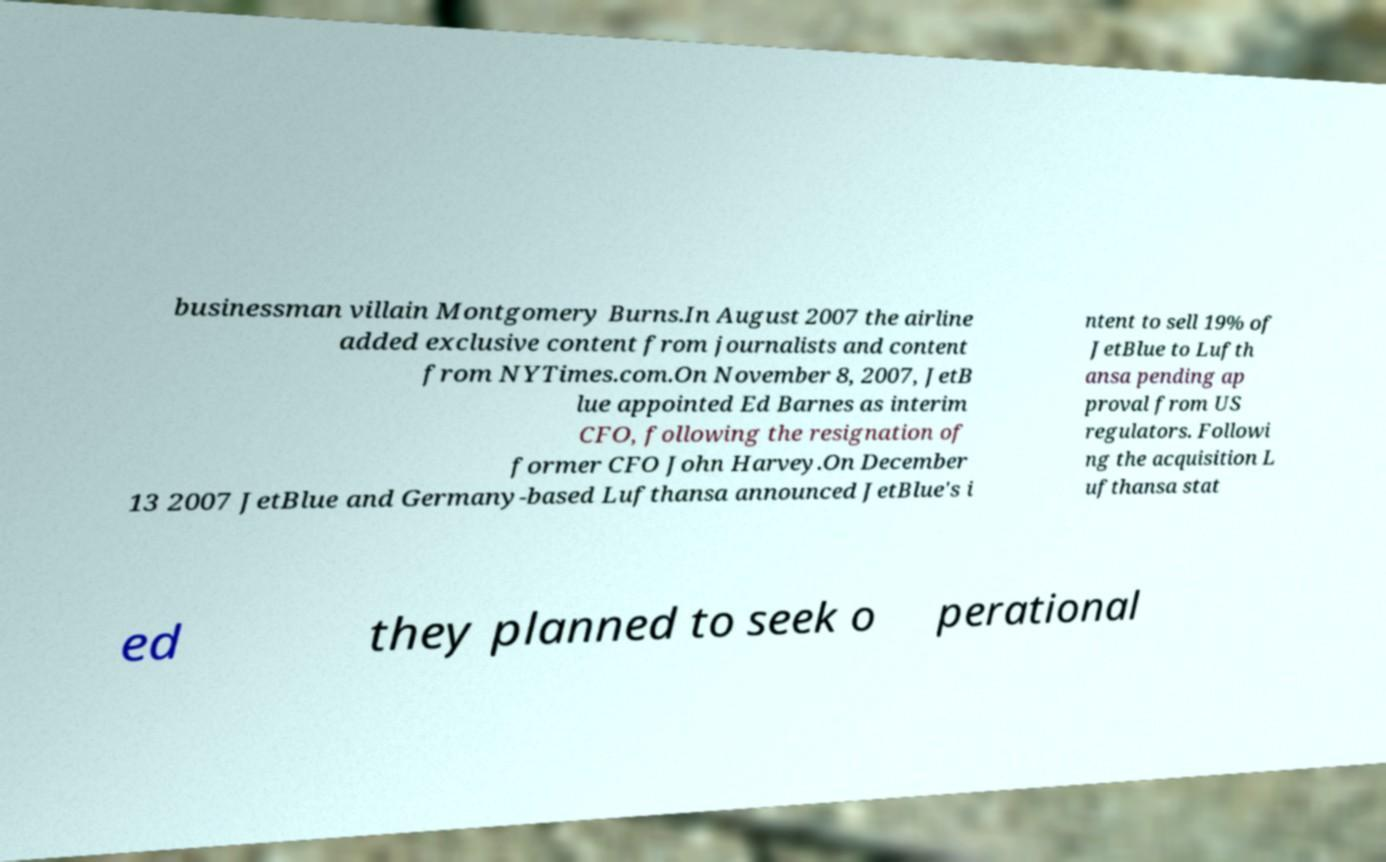Could you extract and type out the text from this image? businessman villain Montgomery Burns.In August 2007 the airline added exclusive content from journalists and content from NYTimes.com.On November 8, 2007, JetB lue appointed Ed Barnes as interim CFO, following the resignation of former CFO John Harvey.On December 13 2007 JetBlue and Germany-based Lufthansa announced JetBlue's i ntent to sell 19% of JetBlue to Lufth ansa pending ap proval from US regulators. Followi ng the acquisition L ufthansa stat ed they planned to seek o perational 